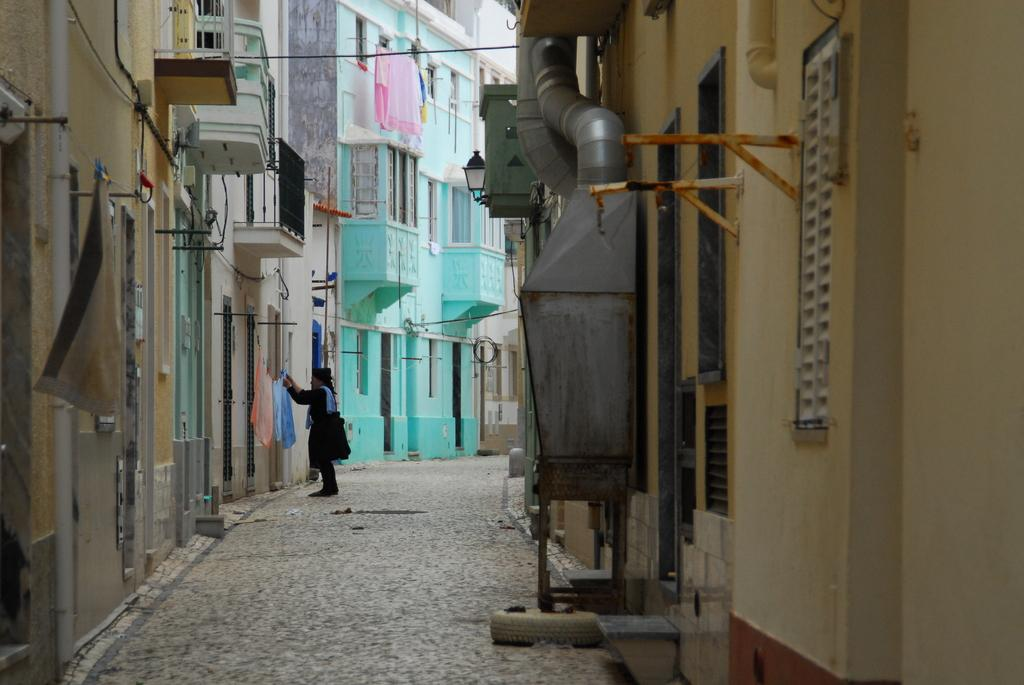What type of structures can be seen in the image? There are buildings in the image. What else is visible in the image besides the buildings? Clothes and a woman are visible in the image. Can you describe the woman in the image? There is a woman in the image, but no specific details about her appearance are provided. What architectural feature can be seen on a wall in the middle of the image? There are pipes on a wall in the middle of the image. What type of porter is carrying the woman in the image? There is no porter or indication of anyone carrying the woman in the image. What type of army is visible in the image? There is no army or military presence visible in the image. 